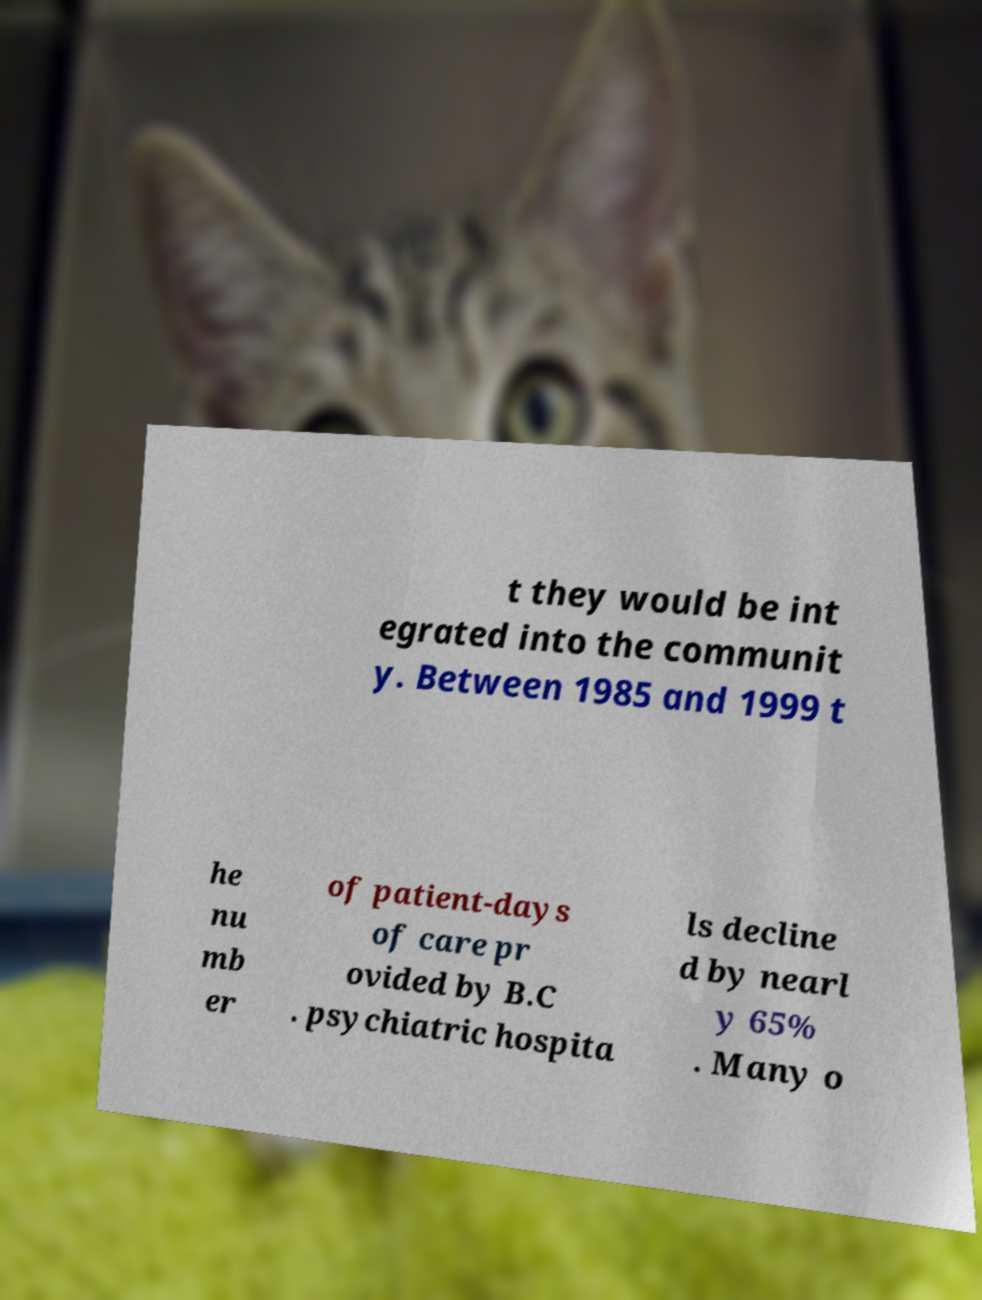For documentation purposes, I need the text within this image transcribed. Could you provide that? t they would be int egrated into the communit y. Between 1985 and 1999 t he nu mb er of patient-days of care pr ovided by B.C . psychiatric hospita ls decline d by nearl y 65% . Many o 